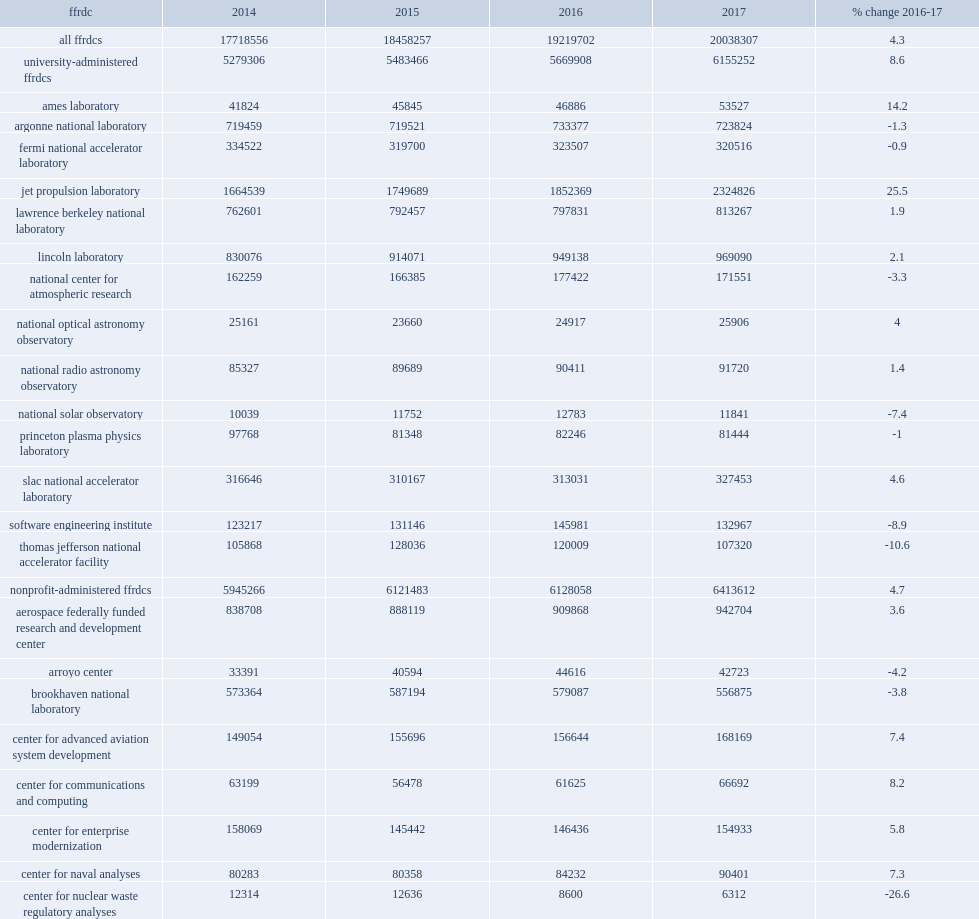How many million dollars did the jet propulsion laboratory reported the largest dollar and percentage increase in r&d of any center increase from fy 2016? 472457. How many percent did the jet propulsion laboratory reported the largest dollar and percentage increase in r&d of any center increase from fy 2016? 25.5. 